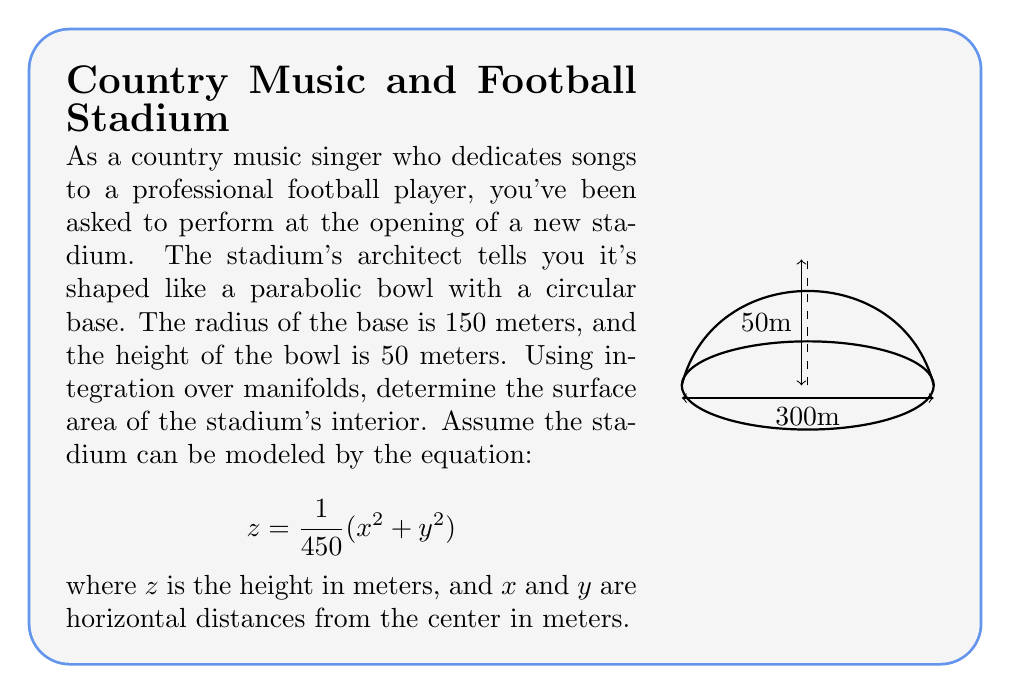What is the answer to this math problem? Let's approach this step-by-step:

1) For a surface described by $z = f(x,y)$, the surface area is given by the double integral:

   $$A = \iint_D \sqrt{1 + (\frac{\partial f}{\partial x})^2 + (\frac{\partial f}{\partial y})^2} \, dA$$

2) In our case, $f(x,y) = \frac{1}{450}(x^2 + y^2)$. Let's calculate the partial derivatives:

   $$\frac{\partial f}{\partial x} = \frac{2x}{450}, \quad \frac{\partial f}{\partial y} = \frac{2y}{450}$$

3) Substituting these into our surface area formula:

   $$A = \iint_D \sqrt{1 + (\frac{2x}{450})^2 + (\frac{2y}{450})^2} \, dA$$

4) Due to the circular symmetry, it's best to use polar coordinates. Let $x = r\cos\theta$ and $y = r\sin\theta$. The Jacobian of this transformation is $r$, so $dA = r \, dr \, d\theta$.

5) Our integral becomes:

   $$A = \int_0^{2\pi} \int_0^{150} \sqrt{1 + (\frac{2r}{450})^2} \, r \, dr \, d\theta$$

6) Simplify the inner integral:

   $$A = 2\pi \int_0^{150} \sqrt{1 + (\frac{r}{225})^2} \, r \, dr$$

7) This integral can be solved using the substitution $u = 1 + (\frac{r}{225})^2$. After substitution and integration, we get:

   $$A = 2\pi \cdot \frac{225^2}{2} \left[\frac{u\sqrt{u}}{3} - \frac{2}{3}\right]_1^{1+(150/225)^2}$$

8) Evaluating the limits and simplifying:

   $$A \approx 71,989.73 \text{ m}^2$$
Answer: $$71,989.73 \text{ m}^2$$ 